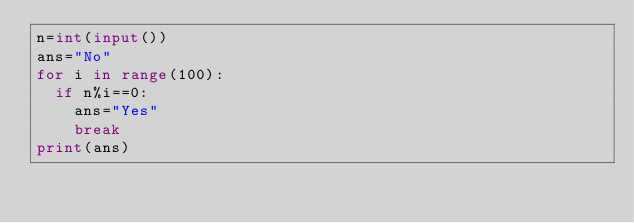Convert code to text. <code><loc_0><loc_0><loc_500><loc_500><_Python_>n=int(input())
ans="No"
for i in range(100):
  if n%i==0:
    ans="Yes"
    break
print(ans)</code> 